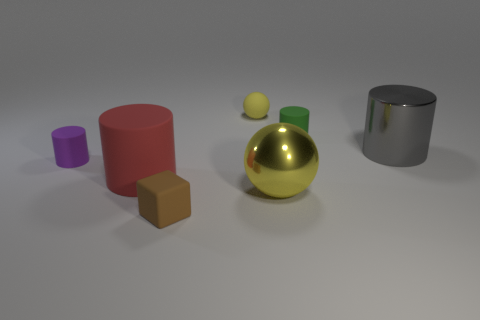Are there any other spheres of the same color as the big shiny ball?
Give a very brief answer. Yes. There is a big object that is the same color as the rubber sphere; what is its material?
Your answer should be compact. Metal. What shape is the gray metal object that is the same size as the red object?
Offer a terse response. Cylinder. There is a small cylinder that is right of the ball behind the tiny matte cylinder that is behind the small purple rubber cylinder; what is it made of?
Your response must be concise. Rubber. Do the big thing that is left of the rubber cube and the yellow thing behind the big gray metal cylinder have the same shape?
Give a very brief answer. No. How many other things are the same material as the big ball?
Keep it short and to the point. 1. Is the material of the yellow ball behind the purple rubber thing the same as the tiny cylinder that is left of the big rubber object?
Offer a very short reply. Yes. The large thing that is made of the same material as the green cylinder is what shape?
Make the answer very short. Cylinder. Is there any other thing that is the same color as the matte ball?
Provide a succinct answer. Yes. How many small purple matte things are there?
Give a very brief answer. 1. 